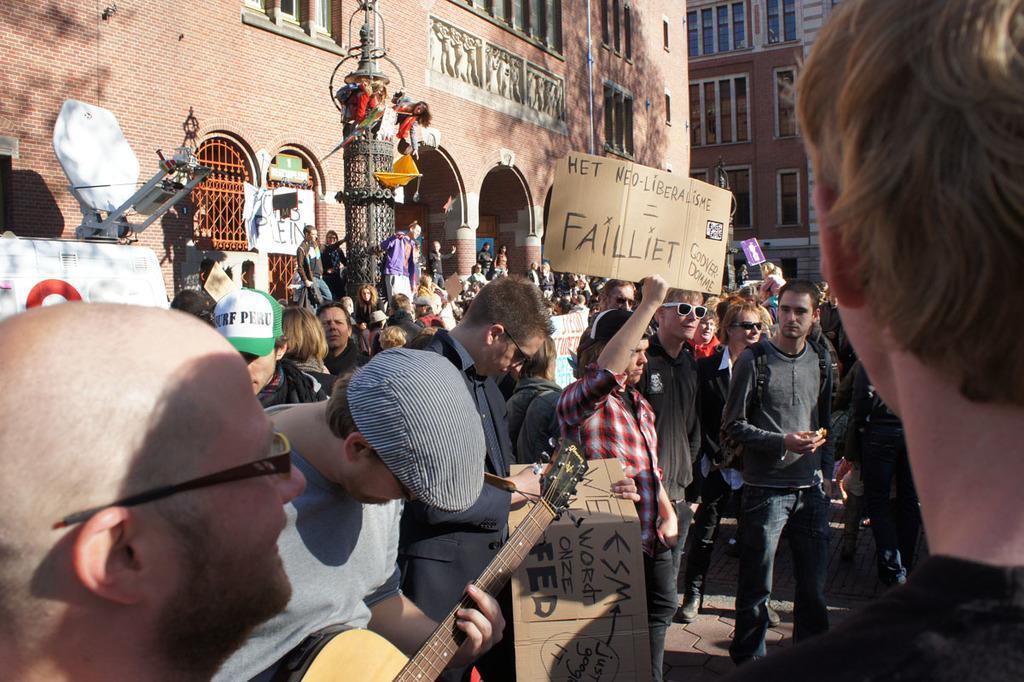Please provide a concise description of this image. This is the picture on the road. There are group of people in the image. The person standing in the front with grey t-shirt is playing guitar, the person with red t- shirt is holding a pluck card. At the back there is building and at the left there is a vehicle and at the bottom there is a road. 